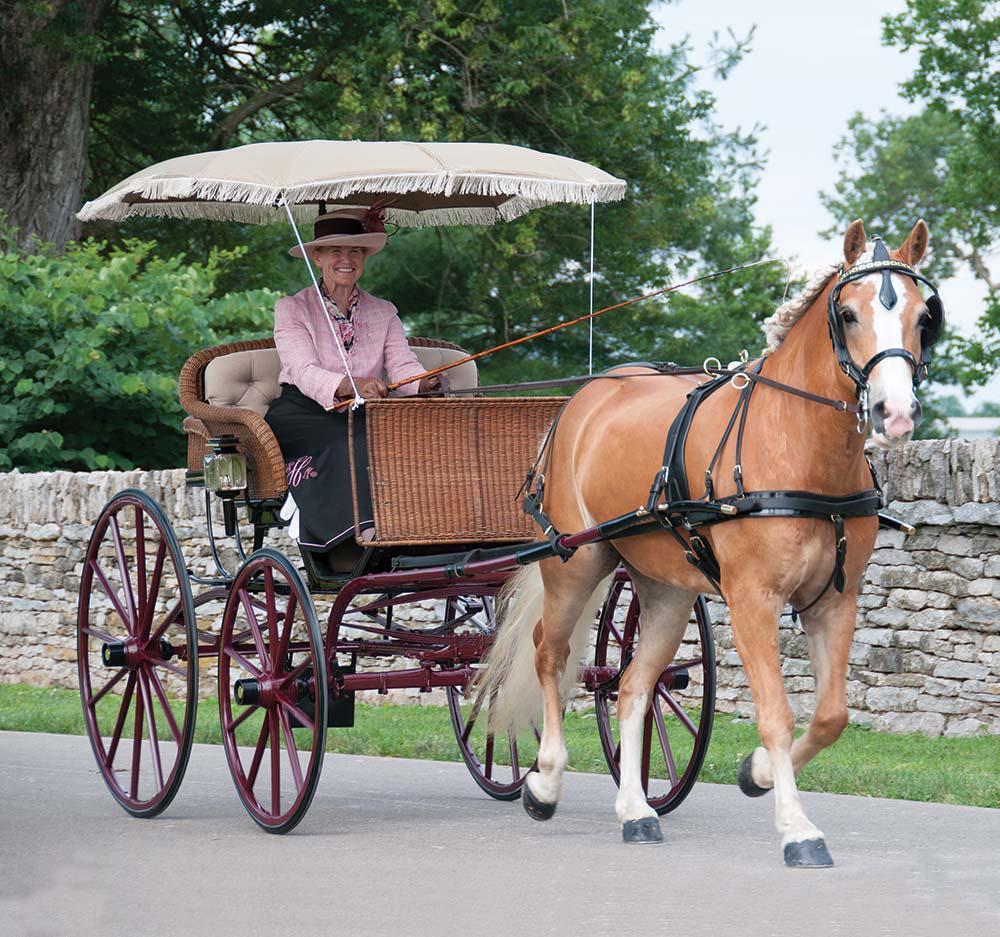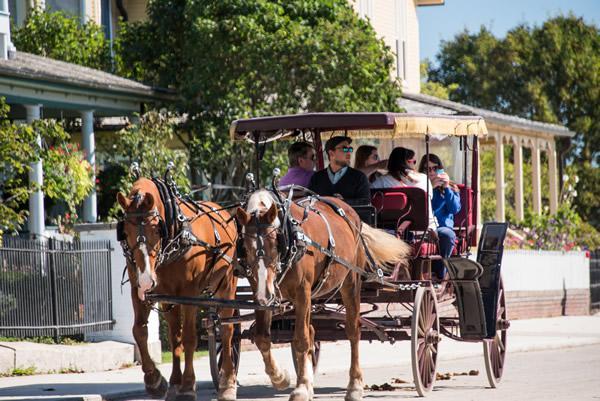The first image is the image on the left, the second image is the image on the right. Given the left and right images, does the statement "There are multiple people being pulled in a carriage in the street by two horses in the right image." hold true? Answer yes or no. Yes. The first image is the image on the left, the second image is the image on the right. Evaluate the accuracy of this statement regarding the images: "There is a carriage without any horses attached to it.". Is it true? Answer yes or no. No. 